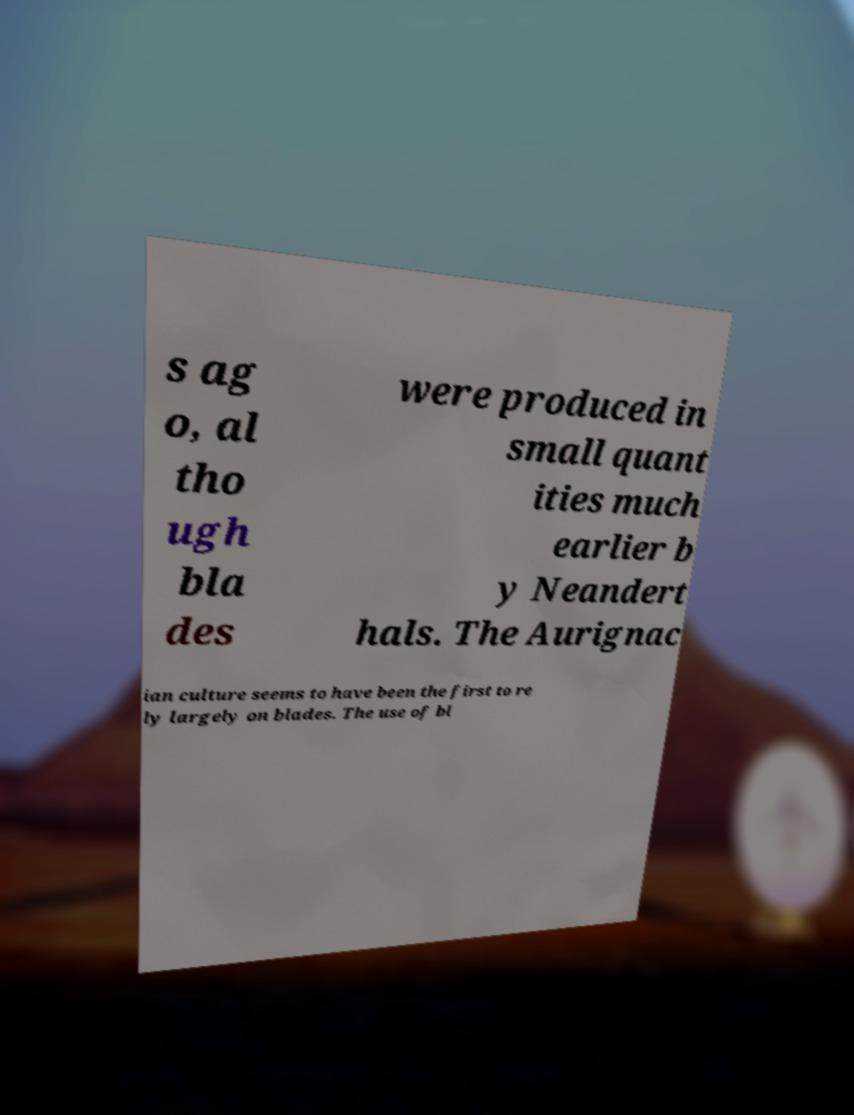Could you assist in decoding the text presented in this image and type it out clearly? s ag o, al tho ugh bla des were produced in small quant ities much earlier b y Neandert hals. The Aurignac ian culture seems to have been the first to re ly largely on blades. The use of bl 